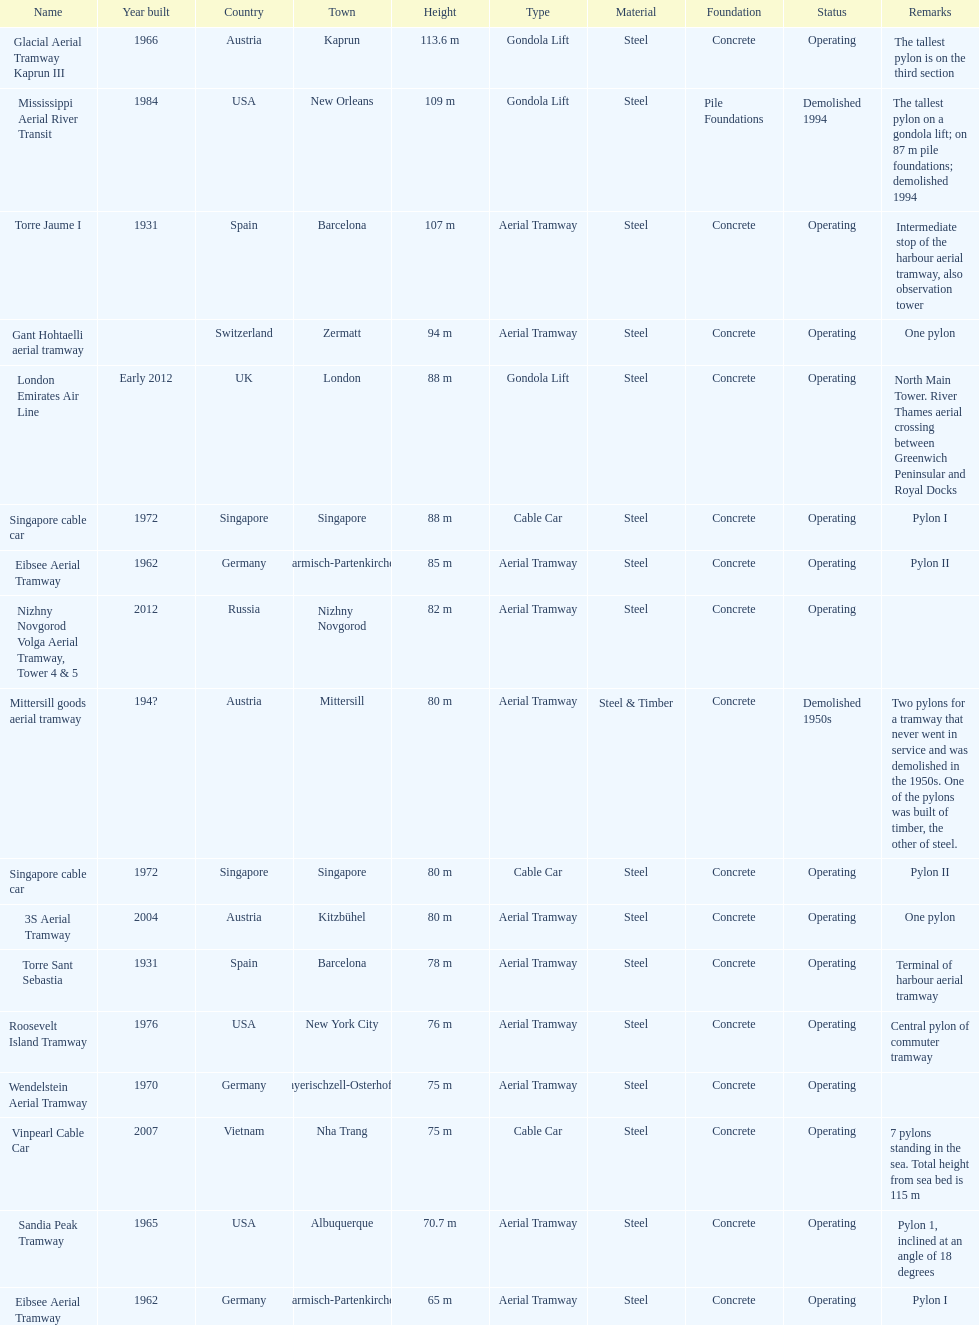How many metres is the tallest pylon? 113.6 m. 